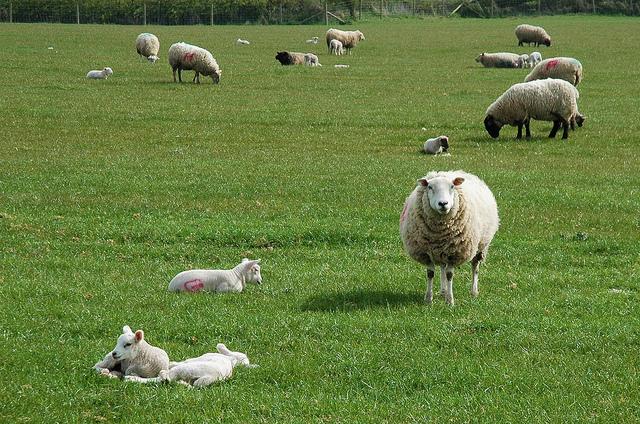What season was this picture taken?
Keep it brief. Summer. Are there babies in the picture?
Be succinct. Yes. Why are there sheep on the grass?
Short answer required. Grazing. What is most of the sheep doing in the picture?
Concise answer only. Laying. 